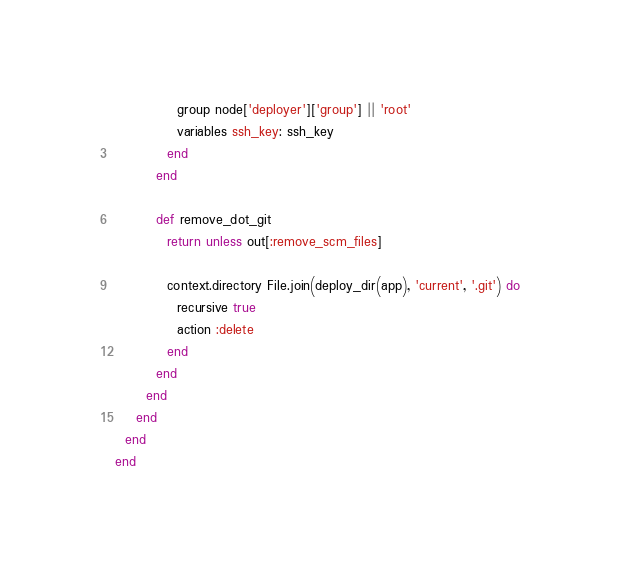Convert code to text. <code><loc_0><loc_0><loc_500><loc_500><_Ruby_>            group node['deployer']['group'] || 'root'
            variables ssh_key: ssh_key
          end
        end

        def remove_dot_git
          return unless out[:remove_scm_files]

          context.directory File.join(deploy_dir(app), 'current', '.git') do
            recursive true
            action :delete
          end
        end
      end
    end
  end
end
</code> 